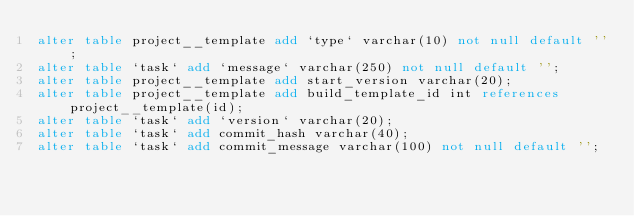<code> <loc_0><loc_0><loc_500><loc_500><_SQL_>alter table project__template add `type` varchar(10) not null default '';
alter table `task` add `message` varchar(250) not null default '';
alter table project__template add start_version varchar(20);
alter table project__template add build_template_id int references project__template(id);
alter table `task` add `version` varchar(20);
alter table `task` add commit_hash varchar(40);
alter table `task` add commit_message varchar(100) not null default '';
</code> 